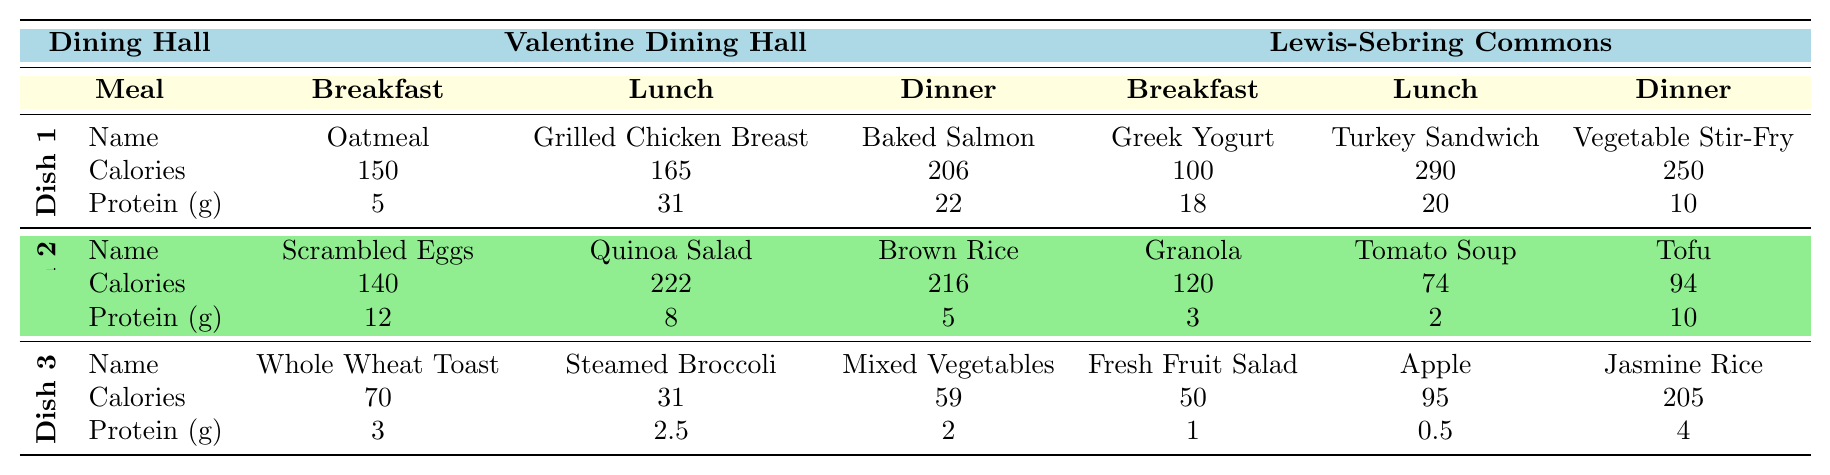What are the calories in the Grilled Chicken Breast? The table lists the calories for Grilled Chicken Breast under the Lunch meal at Valentine Dining Hall, which is 165.
Answer: 165 Which dish has the highest fat content for breakfast? In the breakfast section of the table, the Scrambled Eggs contain 10 g of fat, while the others have lower fat content (Oatmeal has 3 g and Whole Wheat Toast has 1 g).
Answer: Scrambled Eggs What is the total protein content for the Dinner dishes at Valentine Dining Hall? The protein content for Baked Salmon is 22 g, for Brown Rice is 5 g, and for Mixed Vegetables is 2 g. Adding them gives 22 + 5 + 2 = 29 g.
Answer: 29 g Which dining hall offers a lower calorie Lunch option between Valentine Dining Hall and Lewis-Sebring Commons? The Lunch calories for Valentine Dining Hall are 165 for Grilled Chicken Breast, while Lewis-Sebring Commons offers Turkey Sandwich at 290 calories. Since 165 is lower than 290, Valentine Dining Hall has the lower calorie option.
Answer: Valentine Dining Hall Is the protein content in the Quinoa Salad greater than in the Steamed Broccoli? The protein in Quinoa Salad is 8 g, and in Steamed Broccoli, it is 2.5 g. Since 8 is greater than 2.5, the statement is true.
Answer: Yes What are the combined calories for breakfast dishes in Lewis-Sebring Commons? The breakfast dishes are Greek Yogurt (100), Granola (120), and Fresh Fruit Salad (50). Summing these gives 100 + 120 + 50 = 270 calories.
Answer: 270 Which dish has the least amount of carbohydrates overall? Looking at the carbohydrates per dish, Mixed Vegetables have 13 g, while Fresh Fruit Salad has 13 g too, but the lowest is Scrambled Eggs with 2 g.
Answer: Scrambled Eggs What is the average amount of protein in lunch dishes from both dining halls? Valentine Dining Hall's protein is 31 g from Grilled Chicken Breast, and Lewis-Sebring Commons offers 20 g from Turkey Sandwich. The total protein is 31 + 20 = 51 g, and dividing by 2 gives an average of 25.5 g.
Answer: 25.5 g Is there any dish that has zero carbohydrates? Under the Dinner section, Baked Salmon and Grilled Chicken Breast both have 0 g of carbohydrates. Thus, it confirms the existence of such dishes.
Answer: Yes What is the protein difference between the highest and lowest protein breakfast option? The highest is Greek Yogurt with 18 g protein, and the lowest is Fresh Fruit Salad with 1 g. The difference is 18 - 1 = 17 g.
Answer: 17 g 